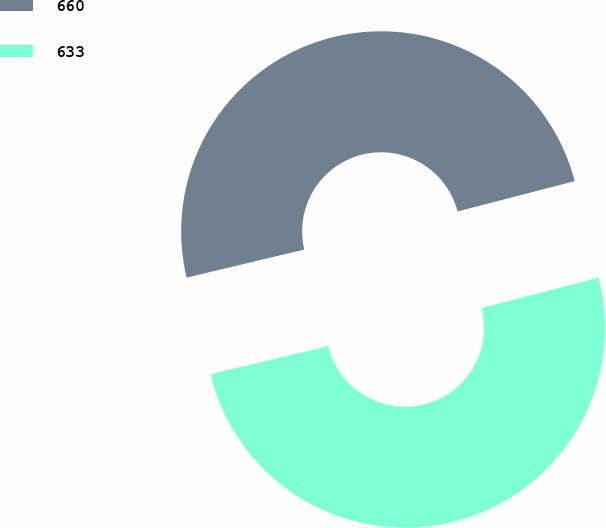Convert chart. <chart><loc_0><loc_0><loc_500><loc_500><pie_chart><fcel>660<fcel>633<nl><fcel>49.69%<fcel>50.31%<nl></chart> 